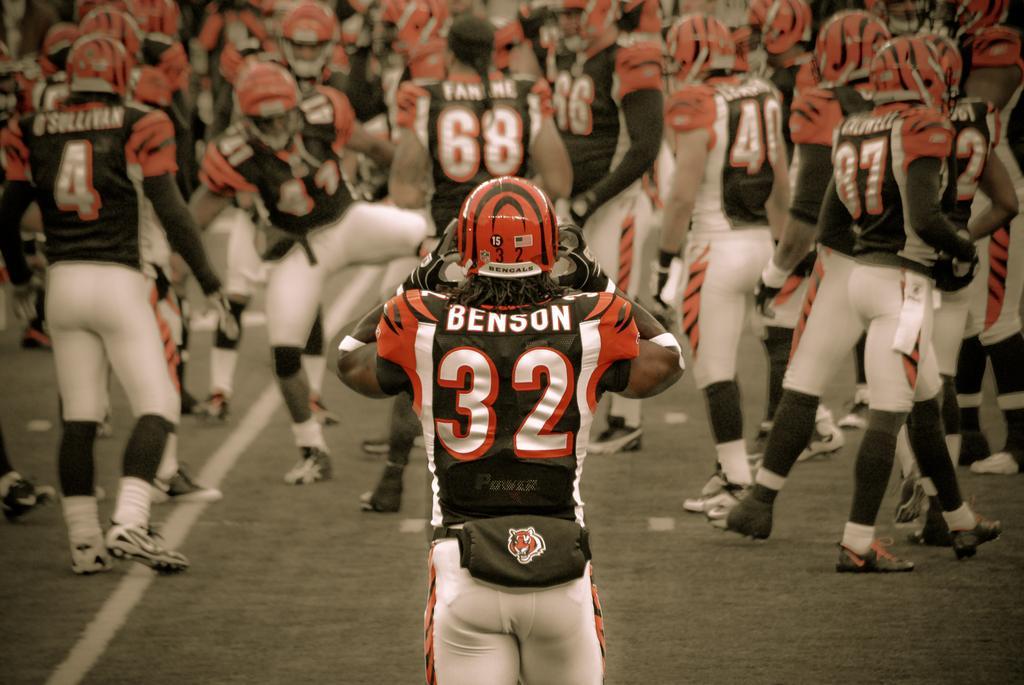In one or two sentences, can you explain what this image depicts? This image is taken outdoors. At the bottom of the image there is a ground. In the middle of the image a man is walking on the ground. In the background there are many people. A few are standing on the ground and a few are walking on the ground. They have worn helmets and T-shirts with text on them. They have worn shoes, gloves and socks. 